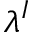<formula> <loc_0><loc_0><loc_500><loc_500>\lambda ^ { I }</formula> 